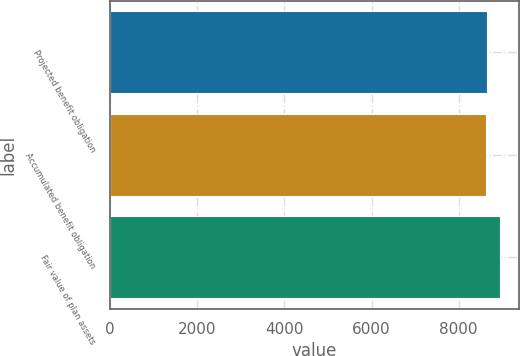Convert chart. <chart><loc_0><loc_0><loc_500><loc_500><bar_chart><fcel>Projected benefit obligation<fcel>Accumulated benefit obligation<fcel>Fair value of plan assets<nl><fcel>8655.2<fcel>8624<fcel>8936<nl></chart> 